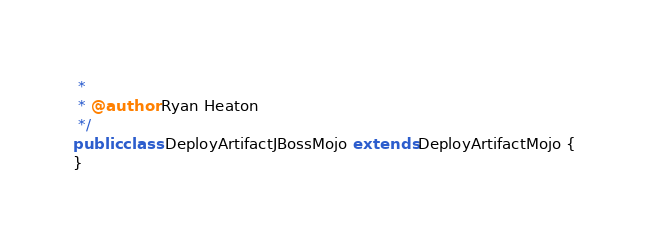Convert code to text. <code><loc_0><loc_0><loc_500><loc_500><_Java_> *
 * @author Ryan Heaton
 */
public class DeployArtifactJBossMojo extends DeployArtifactMojo {
}</code> 